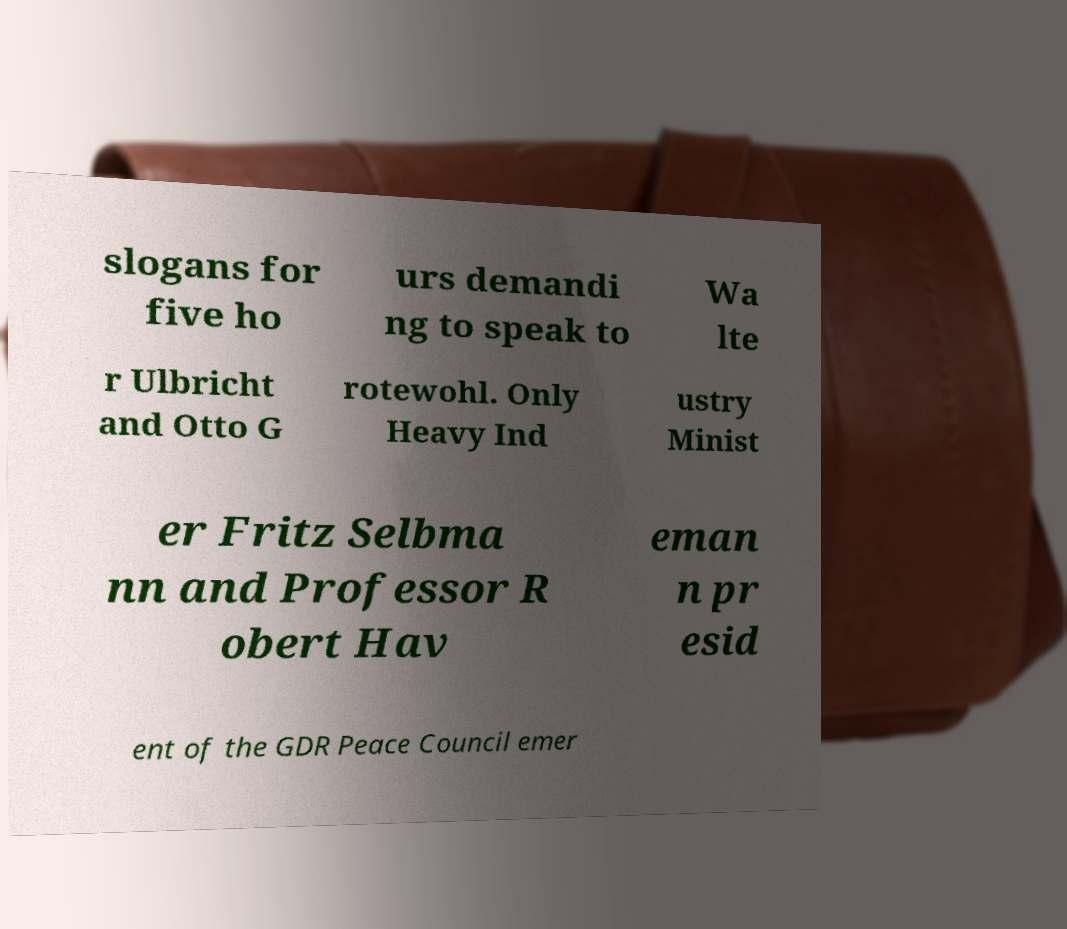There's text embedded in this image that I need extracted. Can you transcribe it verbatim? slogans for five ho urs demandi ng to speak to Wa lte r Ulbricht and Otto G rotewohl. Only Heavy Ind ustry Minist er Fritz Selbma nn and Professor R obert Hav eman n pr esid ent of the GDR Peace Council emer 